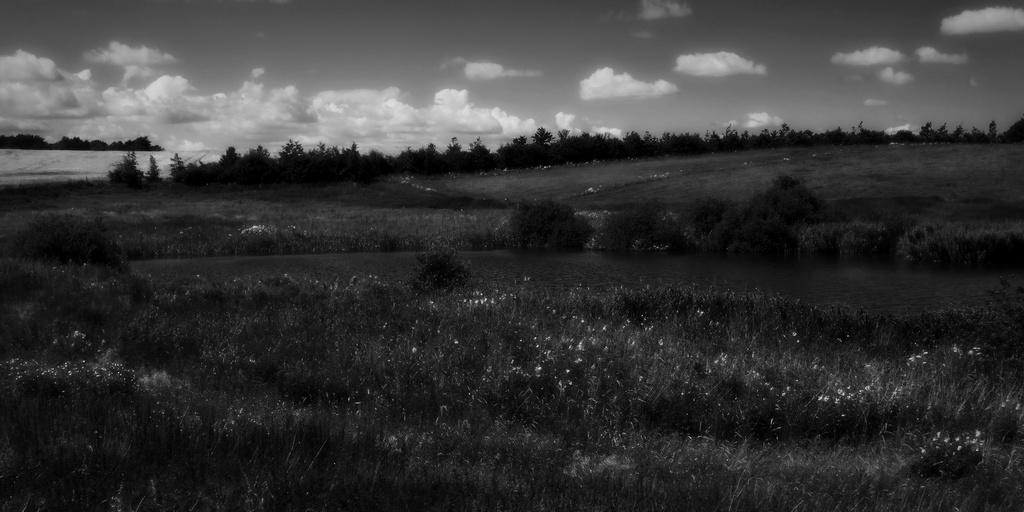What is the color scheme of the image? The image is black and white. What can be seen on the path in the image? There are plants on the path in the image. What is visible behind the plants in the image? There are trees visible behind the plants. How would you describe the sky in the image? The sky is cloudy in the image. What type of cannon is present in the image? There is no cannon present in the image. How many additional plants are there on the path in the image? The provided facts do not specify the number of plants on the path, so it cannot be determined from the image. 